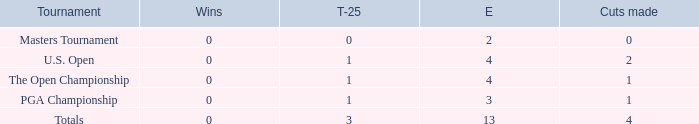How many cuts did he make at the PGA championship in 3 events? None. 